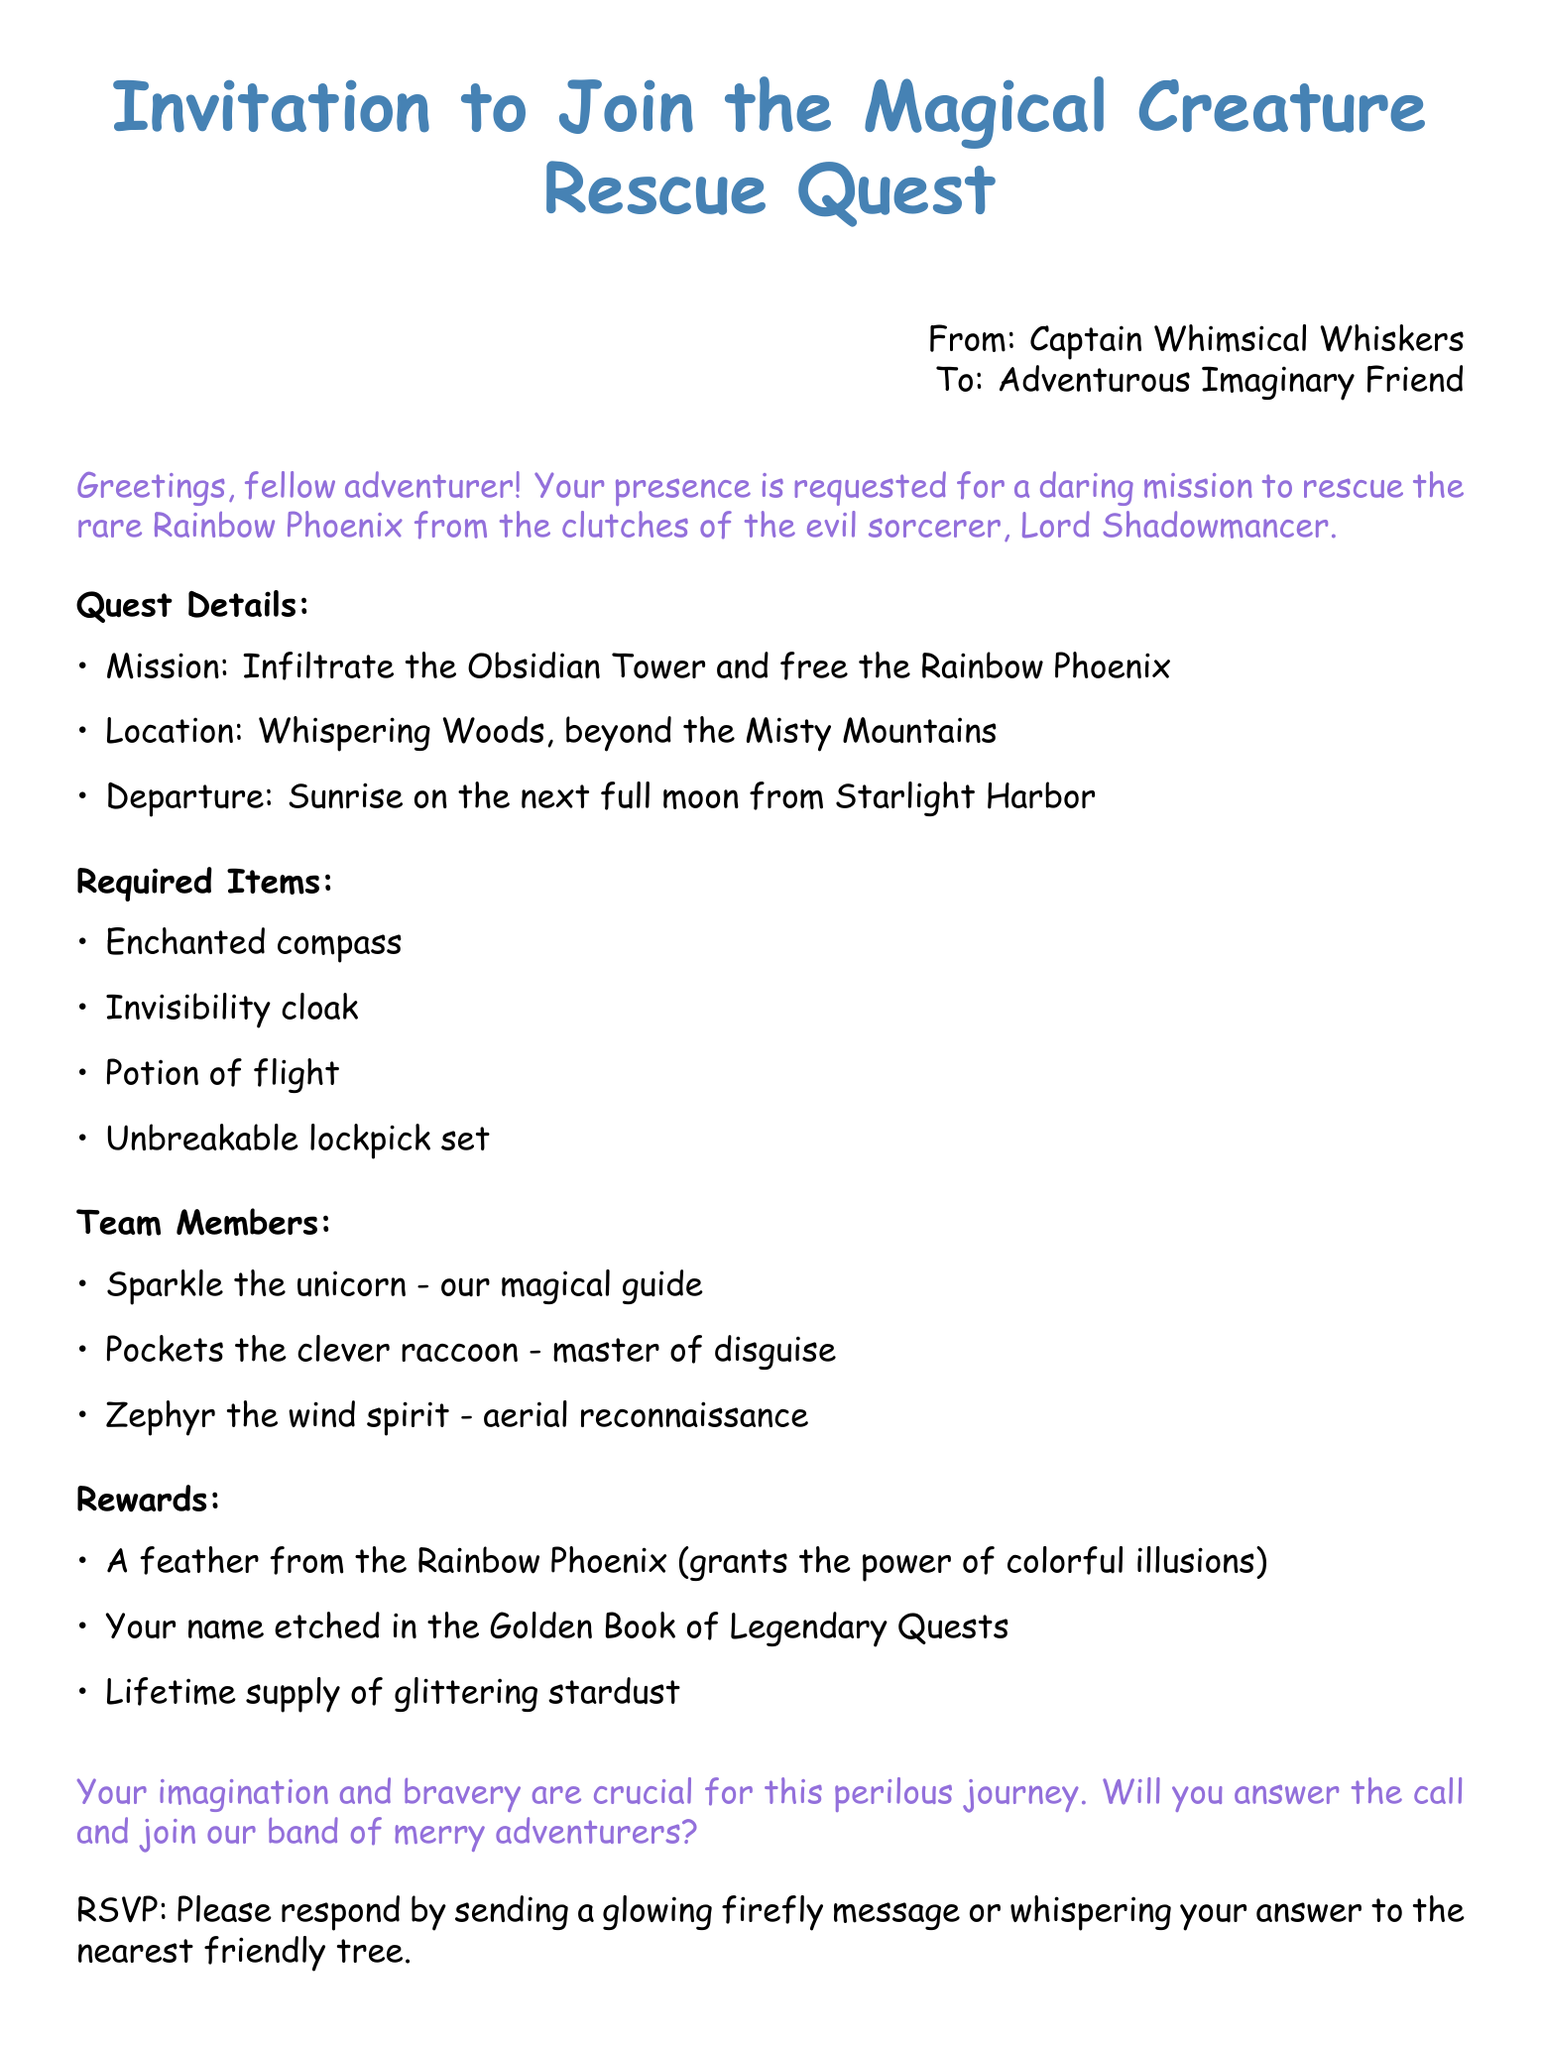What is the name of the magical creature to be rescued? The document states that the rare creature is the Rainbow Phoenix.
Answer: Rainbow Phoenix Who is the evil sorcerer mentioned in the invitation? The document identifies the sorcerer as Lord Shadowmancer.
Answer: Lord Shadowmancer When is the departure time for the quest? The document specifies the departure as Sunrise on the next full moon.
Answer: Sunrise on the next full moon What is required to navigate during the quest? The document lists an enchanted compass as necessary for the quest.
Answer: Enchanted compass Who is the magical guide on the quest? The document refers to Sparkle the unicorn as the magical guide.
Answer: Sparkle the unicorn What type of cloak is required for the mission? The document mentions the need for an invisibility cloak.
Answer: Invisibility cloak How many team members are listed in the document? There are three team members mentioned: Sparkle, Pockets, and Zephyr.
Answer: Three What reward involves a feather from the creature? The document states that the feather grants the power of colorful illusions.
Answer: Colorful illusions How should one respond to the invitation? The document suggests sending a glowing firefly message or whispering to a friendly tree.
Answer: Glowing firefly message or whispering to the nearest friendly tree 